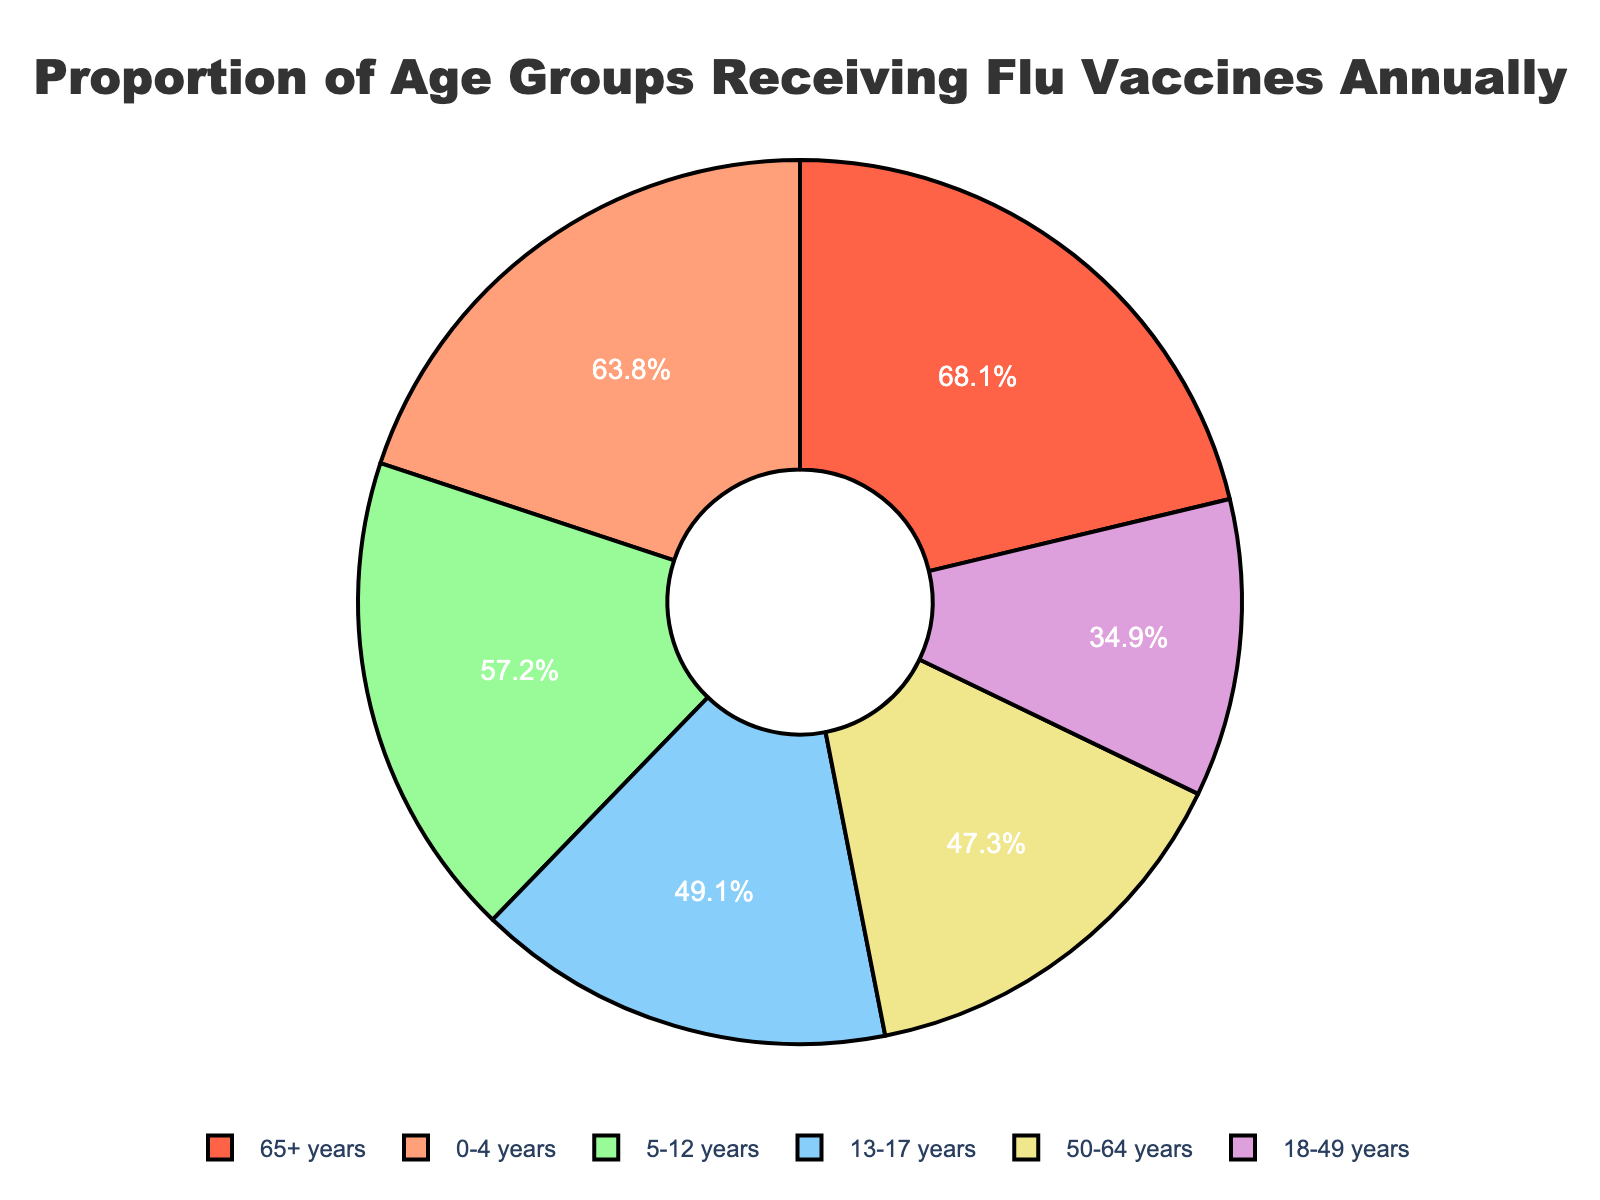What is the percentage of the age group 65+ years receiving flu vaccines? The figure shows the percentage for the age group 65+ years is represented as 68.1%.
Answer: 68.1% Which age group has the lowest percentage of flu vaccine recipients? By comparing the percentages of all age groups, the 18-49 years group has the lowest percentage at 34.9%.
Answer: 18-49 years How much more is the percentage of 0-4 years compared to 5-12 years? Subtract the percentage for 5-12 years (57.2%) from the percentage for 0-4 years (63.8%). 63.8% - 57.2% = 6.6%.
Answer: 6.6% Which age groups have more than 50% of their members receiving flu vaccines? The age groups with percentages above 50% are 0-4 years (63.8%), 5-12 years (57.2%), and 65+ years (68.1%).
Answer: 0-4 years, 5-12 years, 65+ years What is the combined percentage of the age groups 50-64 years and 13-17 years? Add the percentages for 50-64 years (47.3%) and 13-17 years (49.1%). 47.3% + 49.1% = 96.4%.
Answer: 96.4% Is the percentage of flu vaccine recipients in the 65+ years age group greater than the combined percentage of the 18-49 years and 50-64 years age groups? First, find the combined percentage for 18-49 years (34.9%) and 50-64 years (47.3%). 34.9% + 47.3% = 82.2%. The percentage for the 65+ years age group is 68.1%, which is less than 82.2%.
Answer: No Which two age groups have the smallest difference in their percentage of flu vaccine recipients? Calculate the differences between the percentages of all age groups. The smallest difference is between age groups 13-17 years (49.1%) and 50-64 years (47.3%) with a difference of 1.8% (49.1% - 47.3% = 1.8%).
Answer: 13-17 years and 50-64 years What is the average percentage of flu vaccine recipients across all age groups? Sum all the percentages and divide by the number of age groups (6). (63.8% + 57.2% + 49.1% + 34.9% + 47.3% + 68.1%) / 6 = 53.4%.
Answer: 53.4% Which color represents the age group with the highest percentage of flu vaccine recipients? The pie slice with the highest percentage, 68.1% (65+ years), is represented in red.
Answer: Red 